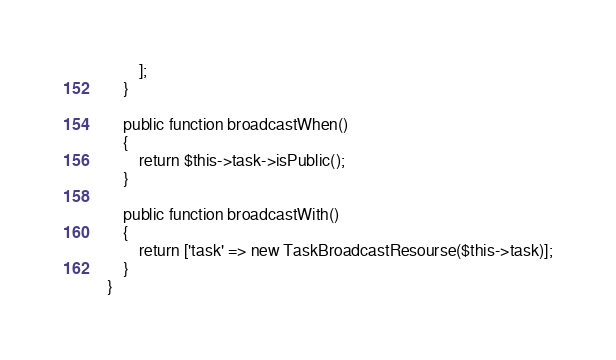Convert code to text. <code><loc_0><loc_0><loc_500><loc_500><_PHP_>        ];
    }

    public function broadcastWhen()
    {
        return $this->task->isPublic();
    }

    public function broadcastWith()
    {
        return ['task' => new TaskBroadcastResourse($this->task)];
    }
}
</code> 